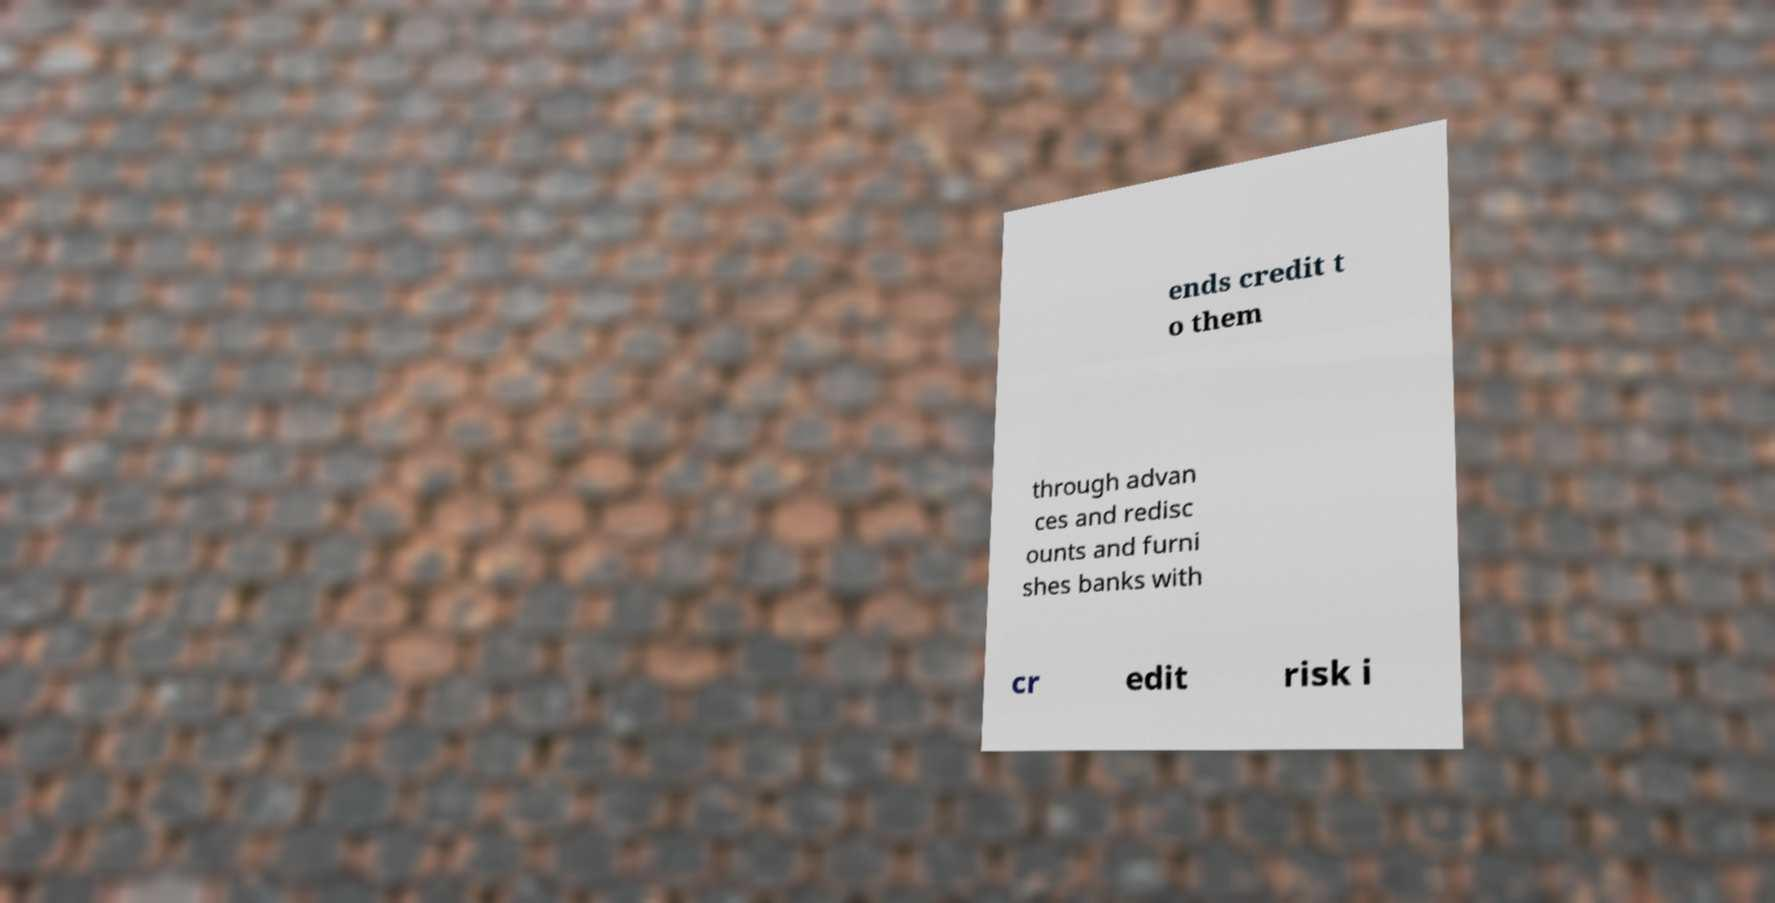Could you extract and type out the text from this image? ends credit t o them through advan ces and redisc ounts and furni shes banks with cr edit risk i 